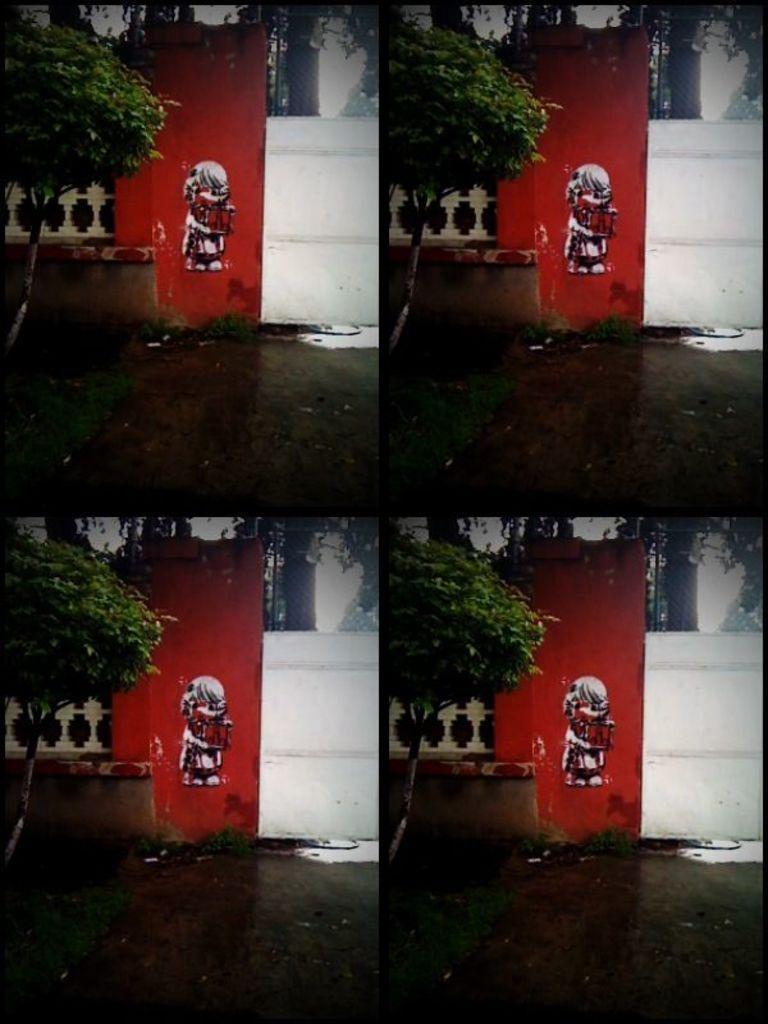Please provide a concise description of this image. This is an edited picture where we can see a image in all the four corners of the image. In the foreground of that image there is a tree, red color wall, white sheet, and the ground. In the background, there is a tree. 